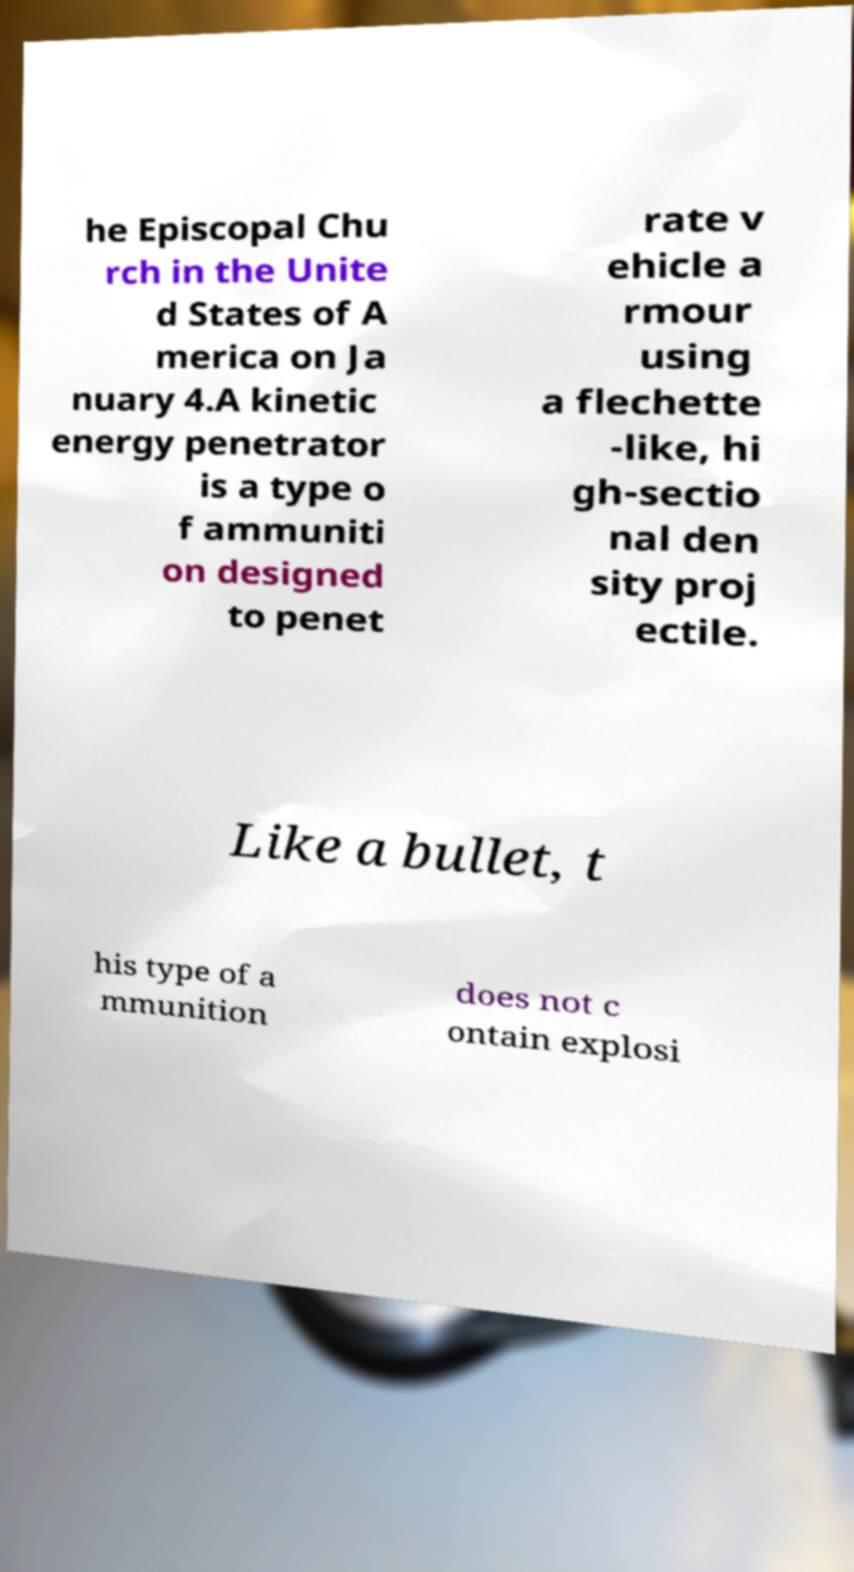Please identify and transcribe the text found in this image. he Episcopal Chu rch in the Unite d States of A merica on Ja nuary 4.A kinetic energy penetrator is a type o f ammuniti on designed to penet rate v ehicle a rmour using a flechette -like, hi gh-sectio nal den sity proj ectile. Like a bullet, t his type of a mmunition does not c ontain explosi 